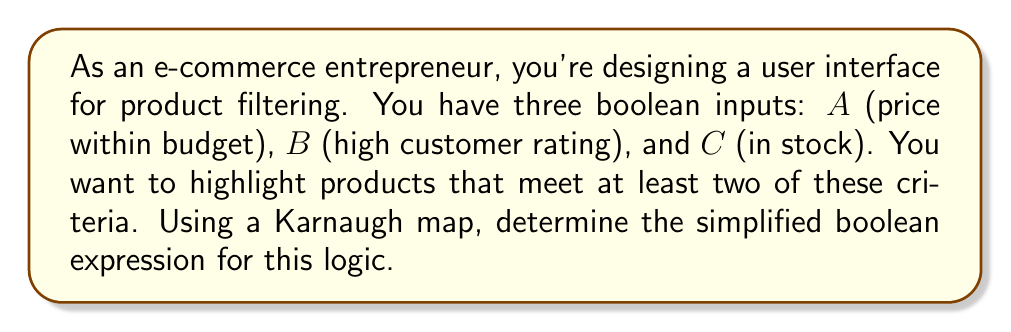Give your solution to this math problem. Let's approach this step-by-step:

1) First, we need to create a Karnaugh map for three variables. The map will have 8 cells (2^3).

2) We'll fill the map based on our requirement: highlight products that meet at least two criteria.

   [asy]
   unitsize(1cm);
   
   draw((0,0)--(2,0)--(2,2)--(0,2)--cycle);
   draw((1,0)--(1,2));
   draw((0,1)--(2,1));
   
   label("$\bar{A}\bar{B}$", (0.5,2.3));
   label("$\bar{A}B$", (1.5,2.3));
   label("$A\bar{B}$", (0.5,-0.3));
   label("$AB$", (1.5,-0.3));
   
   label("$\bar{C}$", (-0.3,1.5));
   label("$C$", (-0.3,0.5));
   
   label("0", (0.5,1.5));
   label("1", (1.5,1.5));
   label("1", (0.5,0.5));
   label("1", (1.5,0.5));
   [/asy]

3) Now, we need to identify the largest possible groups of 1's. We can see two overlapping groups of four 1's:
   - One group covering ABC, AB$\bar{C}$, A$\bar{B}$C, $\bar{A}$BC
   - Another group covering ABC, AB$\bar{C}$, $\bar{A}$BC, A$\bar{B}$C

4) These groups can be represented as:
   - A$\cdot$B + B$\cdot$C
   - A$\cdot$B + A$\cdot$C

5) Either of these expressions is a valid simplification. Let's choose the first one: A$\cdot$B + B$\cdot$C

6) This boolean expression means: (price within budget AND high customer rating) OR (high customer rating AND in stock)

7) In terms of our original variables:
   $$(A \cdot B) + (B \cdot C)$$
Answer: $$(A \cdot B) + (B \cdot C)$$ 